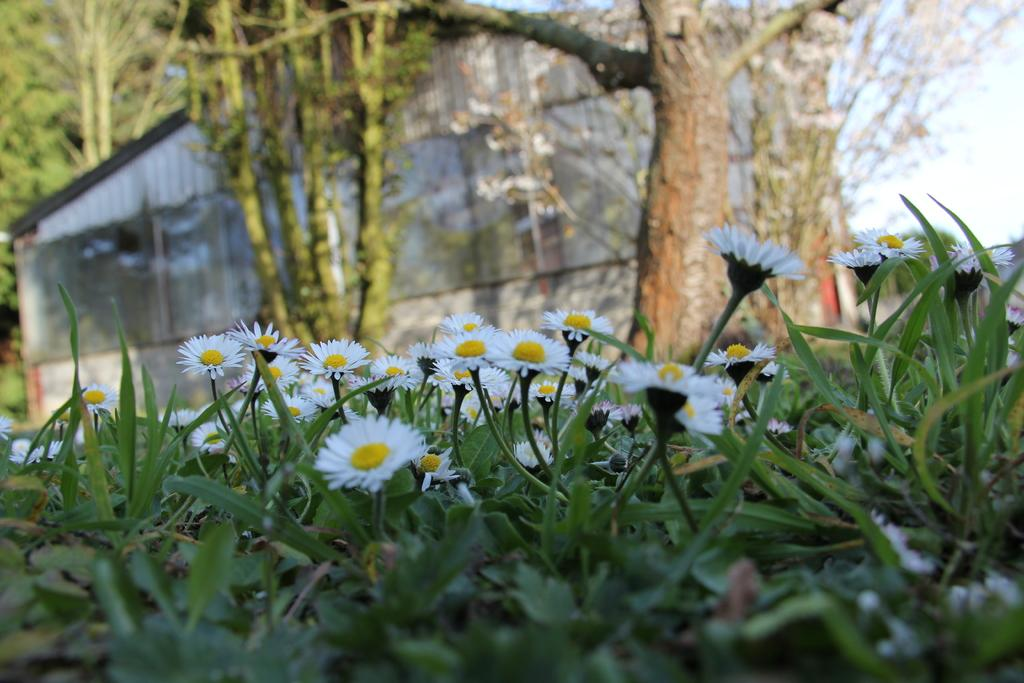What type of plants can be seen in the image? There are plants with flowers in the image. What part of a tree is visible in the image? The bark of a tree is visible on the backside. Can you describe the house in the image? There is a house with a roof in the image. How many trees are present in the image? A group of trees is present in the image. What is the condition of the sky in the image? The sky is visible in the image and appears cloudy. What type of paper is the zebra holding in the image? There is no zebra or paper present in the image. Who is the partner of the house in the image? The image does not depict a partner for the house; it only shows a house with a roof. 